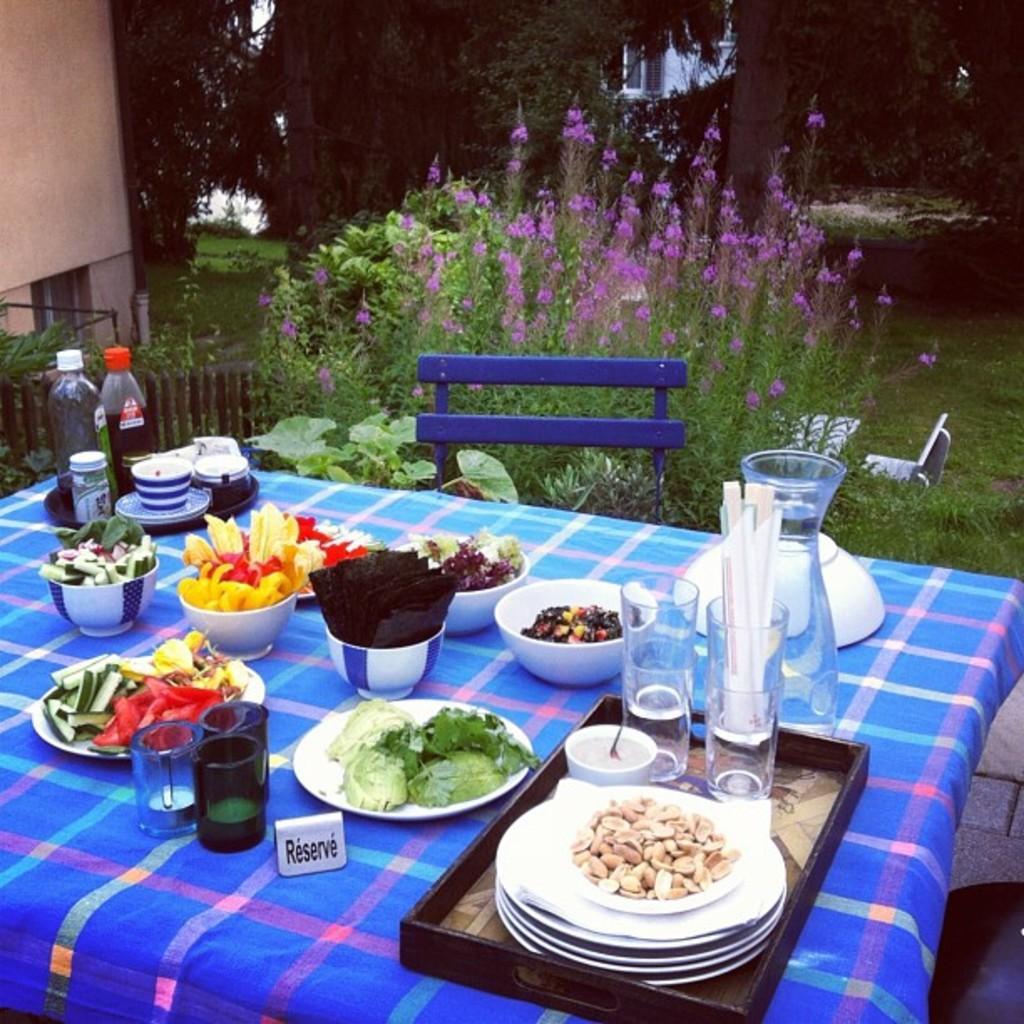Please provide a concise description of this image. In this image I can see the blue color sheet on the table. On the sheet I can see the tray, plates, bottles, glasses, cups, bowls and these are filled with food and drink. And the food is colorful. These plates are in white color. To the side I can see the chairs. In the back I can see the pink color flowers to the plant. In the background I can see the wall of the building, trees and the railing. 